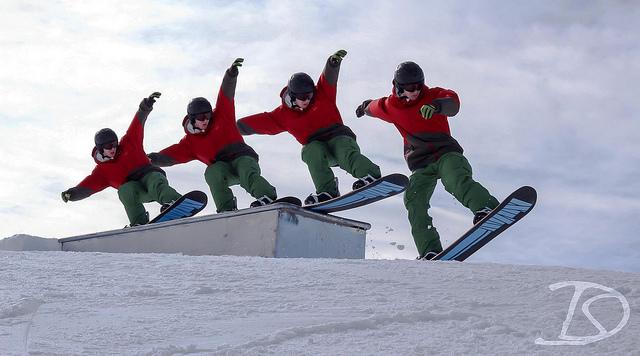What number of men are riding a snowboard?
Concise answer only. 4. What sport is this?
Short answer required. Snowboarding. What is the color of the jacket?
Be succinct. Red. Are all the snowboarders real?
Short answer required. No. What color is this person's jacket?
Keep it brief. Red. 